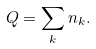Convert formula to latex. <formula><loc_0><loc_0><loc_500><loc_500>Q = \sum _ { k } n _ { k } .</formula> 